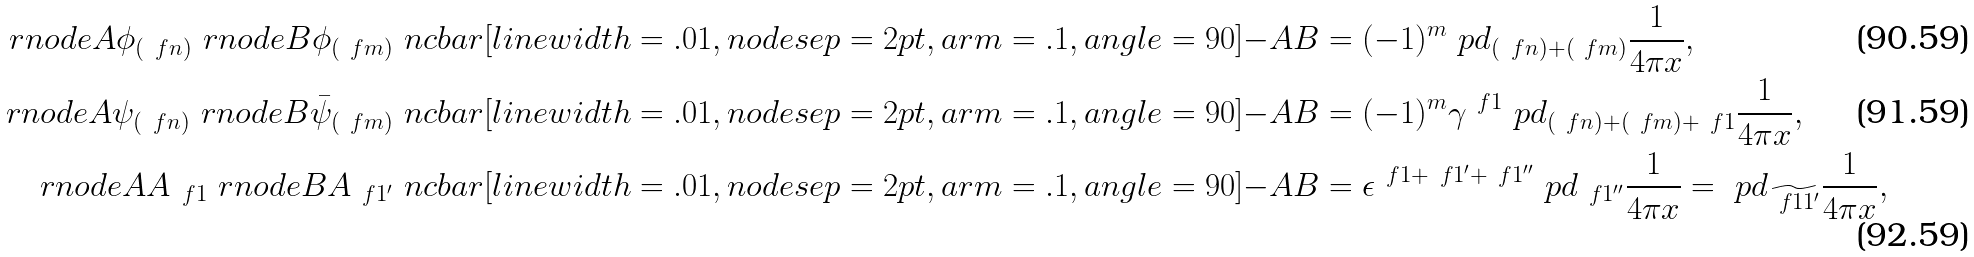<formula> <loc_0><loc_0><loc_500><loc_500>\ r n o d e { A } { \phi } _ { ( \ f { n } ) } \ r n o d e { B } { \phi } _ { ( \ f { m } ) } \ n c b a r [ l i n e w i d t h = . 0 1 , n o d e s e p = 2 p t , a r m = . 1 , a n g l e = 9 0 ] { - } { A } { B } & = ( - 1 ) ^ { m } \ p d _ { ( \ f { n } ) + ( \ f { m } ) } \frac { 1 } { 4 \pi x } , \\ \ r n o d e { A } { \psi } _ { ( \ f { n } ) } \ r n o d e { B } { \bar { \psi } } _ { ( \ f { m } ) } \ n c b a r [ l i n e w i d t h = . 0 1 , n o d e s e p = 2 p t , a r m = . 1 , a n g l e = 9 0 ] { - } { A } { B } & = ( - 1 ) ^ { m } \gamma ^ { \ f { 1 } } \ p d _ { ( \ f { n } ) + ( \ f { m } ) + \ f { 1 } } \frac { 1 } { 4 \pi x } , \\ \ r n o d e { A } { A } _ { \ f 1 } \ r n o d e { B } { A } _ { \ f 1 ^ { \prime } } \ n c b a r [ l i n e w i d t h = . 0 1 , n o d e s e p = 2 p t , a r m = . 1 , a n g l e = 9 0 ] { - } { A } { B } & = \epsilon ^ { \ f 1 + \ f 1 ^ { \prime } + \ f 1 ^ { \prime \prime } } \ p d _ { \ f 1 ^ { \prime \prime } } \frac { 1 } { 4 \pi x } = \ p d _ { \widetilde { \ f { 1 1 ^ { \prime } } } } \frac { 1 } { 4 \pi x } ,</formula> 